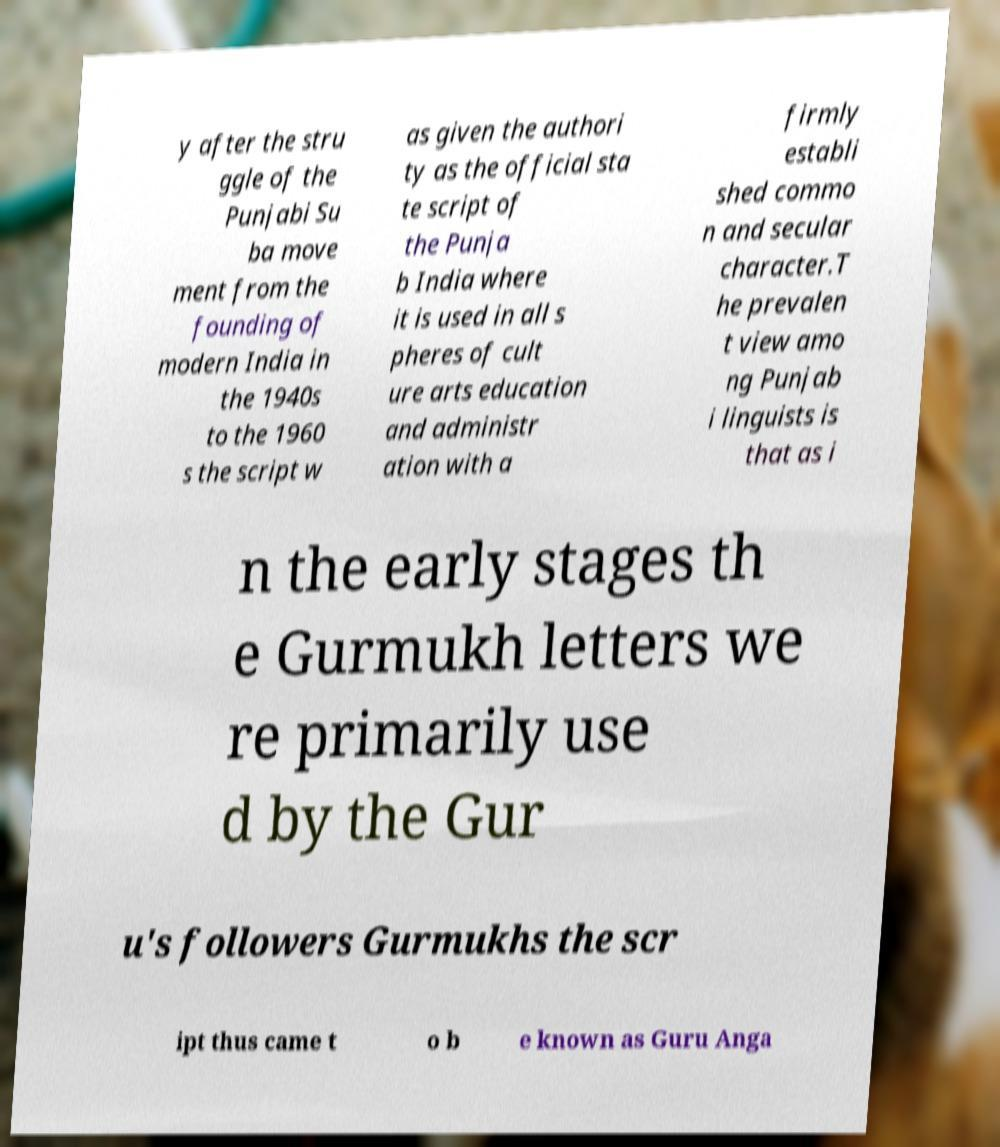Please read and relay the text visible in this image. What does it say? y after the stru ggle of the Punjabi Su ba move ment from the founding of modern India in the 1940s to the 1960 s the script w as given the authori ty as the official sta te script of the Punja b India where it is used in all s pheres of cult ure arts education and administr ation with a firmly establi shed commo n and secular character.T he prevalen t view amo ng Punjab i linguists is that as i n the early stages th e Gurmukh letters we re primarily use d by the Gur u's followers Gurmukhs the scr ipt thus came t o b e known as Guru Anga 